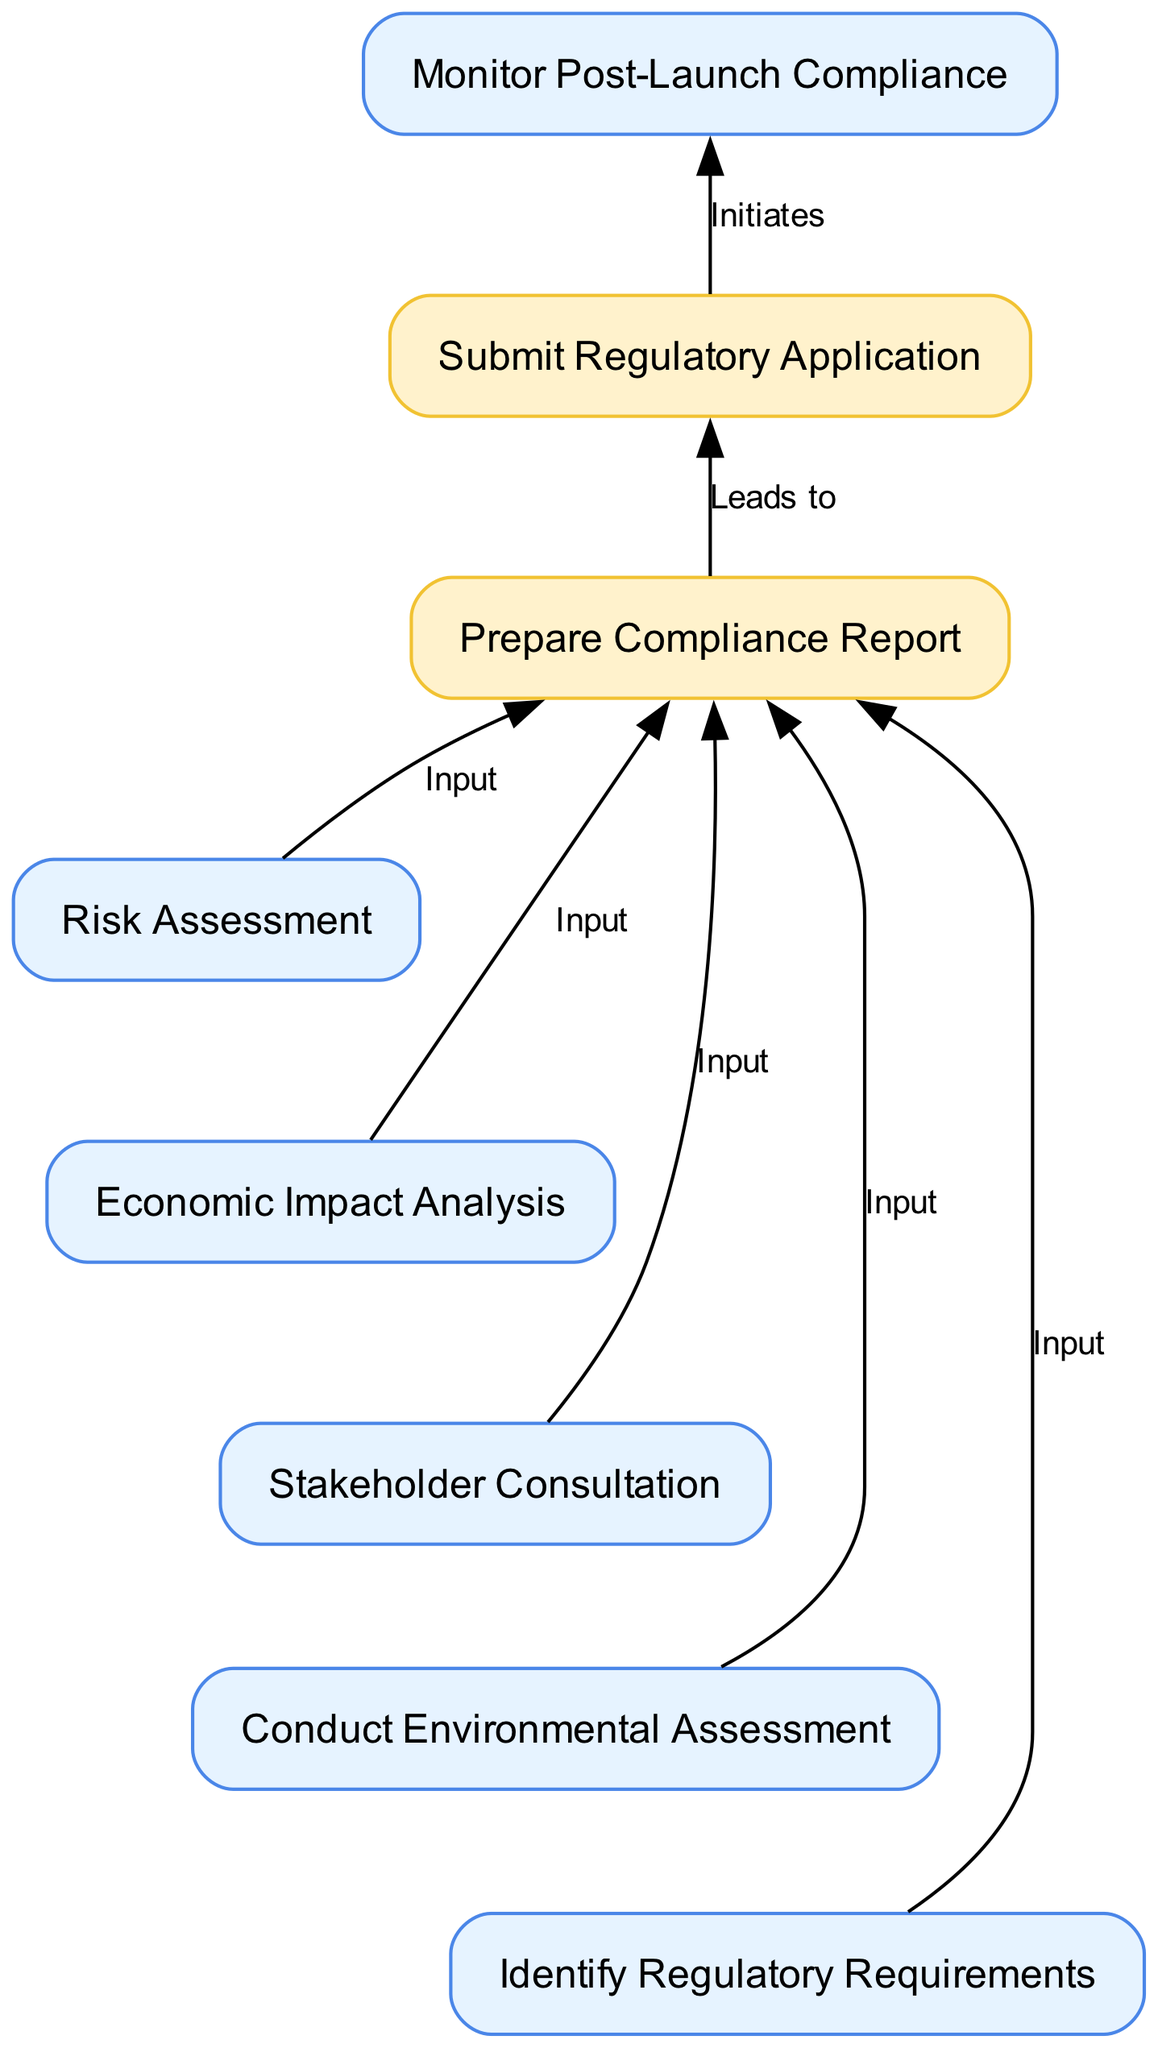What is the first process in the diagram? The first process in the diagram is represented by node '1', which indicates "Identify Regulatory Requirements." Therefore, this is the starting point of the flow chart where the process begins.
Answer: Identify Regulatory Requirements How many process nodes are in the diagram? The diagram shows a total of five process nodes labeled from '1' to '5'. Each node represents a distinct process that contributes to the overall regulatory impact assessment.
Answer: 5 What follows after the "Prepare Compliance Report"? The "Prepare Compliance Report" is directly followed by the node labeled '7', which is "Submit Regulatory Application." This indicates the next step after preparing the report is to file the necessary applications.
Answer: Submit Regulatory Application What is the last output in the diagram? The last output in the flow chart is represented by node '7', which indicates "Submit Regulatory Application." This signifies the conclusion of the main processes leading to an actionable output relating to regulatory compliance.
Answer: Submit Regulatory Application Which two processes are input for the "Prepare Compliance Report"? The "Prepare Compliance Report" node is an output that takes inputs from multiple processes. Among these, "Conduct Environmental Assessment" labeled as node '2' and "Risk Assessment" labeled as node '5' are two of the inputs for this report. Each process contributes findings necessary for compliance.
Answer: Conduct Environmental Assessment, Risk Assessment What type of assessment is represented by node '4'? Node '4' is labeled "Economic Impact Analysis," which indicates that this assessment focuses on evaluating the economic implications of the satellite launch including benefits and costs. This is one of the critical assessments in the regulatory impact assessment flow.
Answer: Economic Impact Analysis How does "Stakeholder Consultation" influence the "Prepare Compliance Report"? The "Stakeholder Consultation" node ('3') provides important feedback and insights from relevant stakeholders, which informs the findings compiled in the "Prepare Compliance Report" ('6'). This input ensures that the report reflects the views and concerns of those affected by the satellite launch.
Answer: It provides input for the report What is the purpose of the "Monitor Post-Launch Compliance" process? The "Monitor Post-Launch Compliance" process ensures that ongoing regulatory compliance is maintained after the satellite launch. It focuses on monitoring frequency usage and environmental impacts to adhere to regulations that continue to apply post-launch.
Answer: Ongoing compliance monitoring 